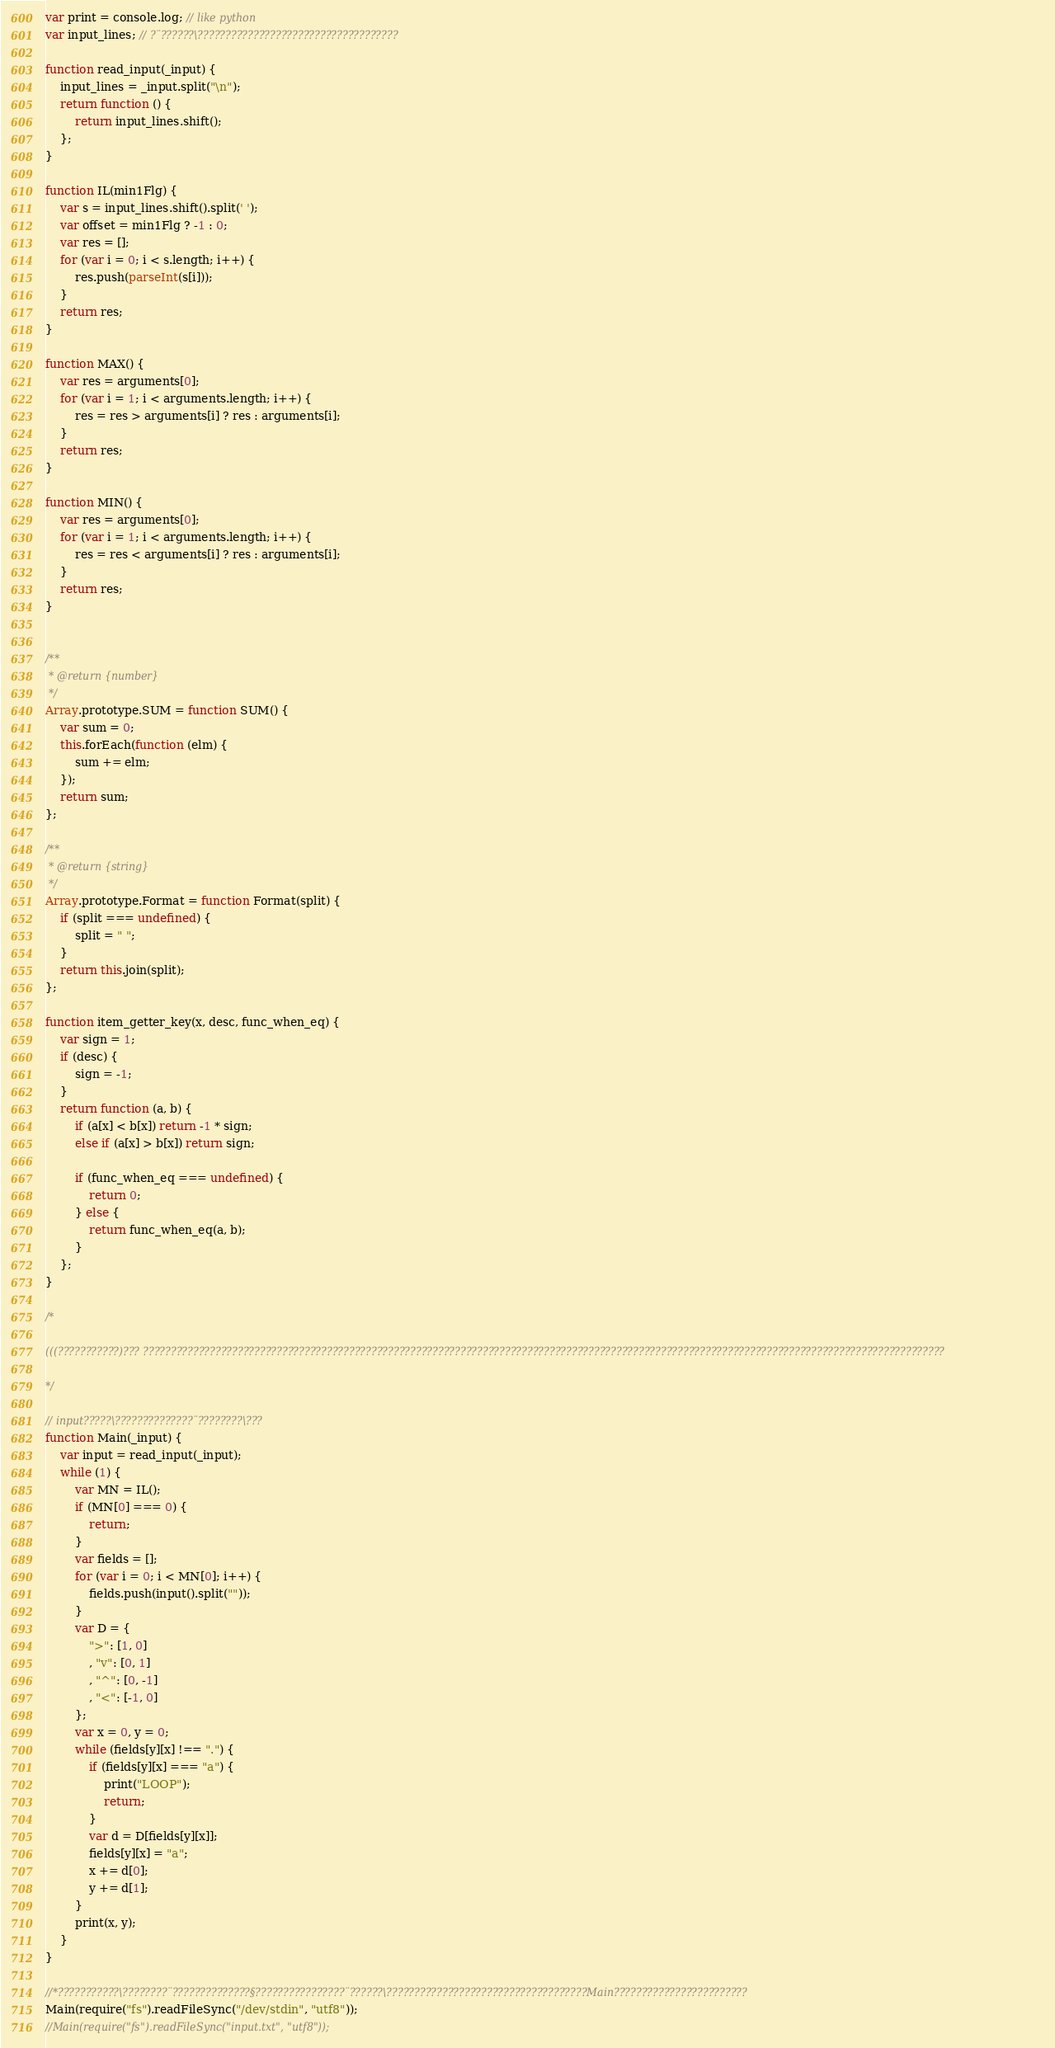<code> <loc_0><loc_0><loc_500><loc_500><_JavaScript_>var print = console.log; // like python
var input_lines; // ?¨??????\????????????????????????????????????

function read_input(_input) {
    input_lines = _input.split("\n");
    return function () {
        return input_lines.shift();
    };
}

function IL(min1Flg) {
    var s = input_lines.shift().split(' ');
    var offset = min1Flg ? -1 : 0;
    var res = [];
    for (var i = 0; i < s.length; i++) {
        res.push(parseInt(s[i]));
    }
    return res;
}

function MAX() {
    var res = arguments[0];
    for (var i = 1; i < arguments.length; i++) {
        res = res > arguments[i] ? res : arguments[i];
    }
    return res;
}

function MIN() {
    var res = arguments[0];
    for (var i = 1; i < arguments.length; i++) {
        res = res < arguments[i] ? res : arguments[i];
    }
    return res;
}


/**
 * @return {number}
 */
Array.prototype.SUM = function SUM() {
    var sum = 0;
    this.forEach(function (elm) {
        sum += elm;
    });
    return sum;
};

/**
 * @return {string}
 */
Array.prototype.Format = function Format(split) {
    if (split === undefined) {
        split = " ";
    }
    return this.join(split);
};

function item_getter_key(x, desc, func_when_eq) {
    var sign = 1;
    if (desc) {
        sign = -1;
    }
    return function (a, b) {
        if (a[x] < b[x]) return -1 * sign;
        else if (a[x] > b[x]) return sign;

        if (func_when_eq === undefined) {
            return 0;
        } else {
            return func_when_eq(a, b);
        }
    };
}

/*

(((???????????)??? ????????????????????????????????????????????????????????????????????????????????????????????????????????????????????????????????????????????????

*/

// input?????\??????????????¨????????\???
function Main(_input) {
    var input = read_input(_input);
    while (1) {
        var MN = IL();
        if (MN[0] === 0) {
            return;
        }
        var fields = [];
        for (var i = 0; i < MN[0]; i++) {
            fields.push(input().split(""));
        }
        var D = {
            ">": [1, 0]
            , "v": [0, 1]
            , "^": [0, -1]
            , "<": [-1, 0]
        };
        var x = 0, y = 0;
        while (fields[y][x] !== ".") {
            if (fields[y][x] === "a") {
                print("LOOP");
                return;
            }
            var d = D[fields[y][x]];
            fields[y][x] = "a";
            x += d[0];
            y += d[1];
        }
        print(x, y);
    }
}

//*???????????\????????¨??????????????§????????????????¨??????\????????????????????????????????????Main????????????????????????
Main(require("fs").readFileSync("/dev/stdin", "utf8"));
//Main(require("fs").readFileSync("input.txt", "utf8"));</code> 